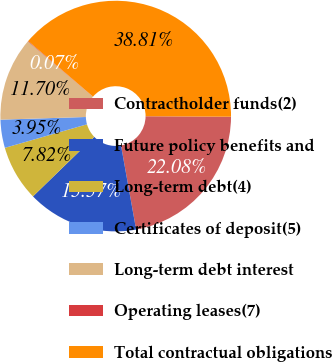Convert chart to OTSL. <chart><loc_0><loc_0><loc_500><loc_500><pie_chart><fcel>Contractholder funds(2)<fcel>Future policy benefits and<fcel>Long-term debt(4)<fcel>Certificates of deposit(5)<fcel>Long-term debt interest<fcel>Operating leases(7)<fcel>Total contractual obligations<nl><fcel>22.08%<fcel>15.57%<fcel>7.82%<fcel>3.95%<fcel>11.7%<fcel>0.07%<fcel>38.81%<nl></chart> 